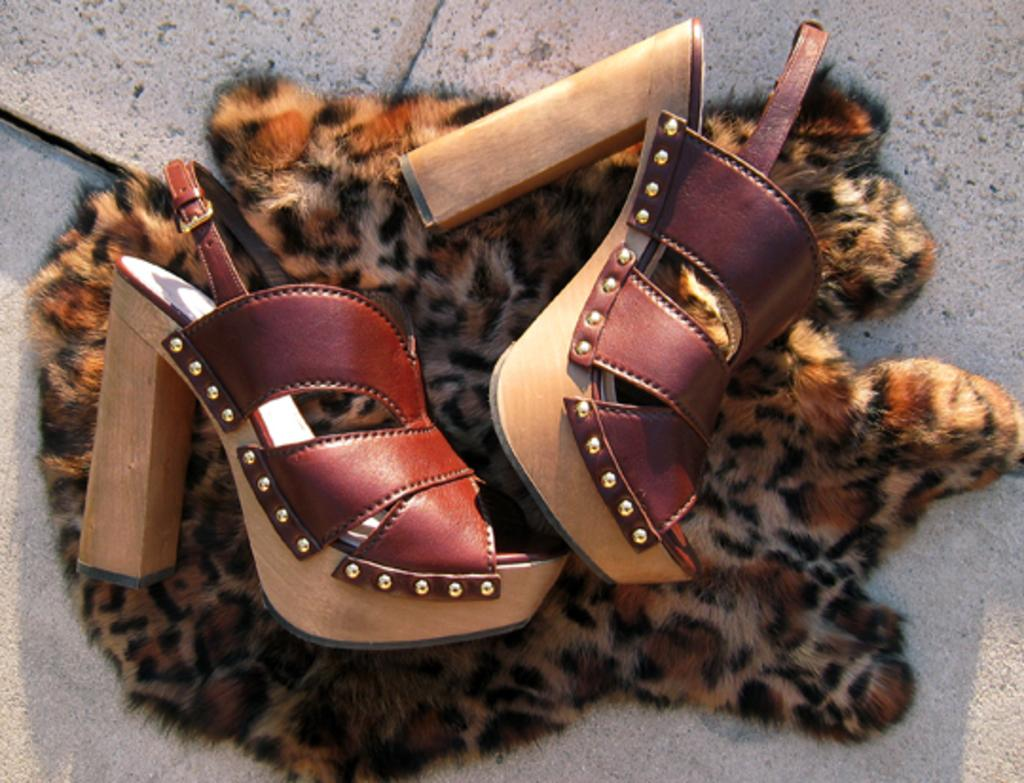What can be seen in the image? There is an object and sandals in the image. What type of footwear is present in the image? There are sandals in the image. Where are the object and sandals located? Both the object and sandals are on a surface. What type of lock is used to secure the sandals in the image? There is no lock present in the image; the sandals are simply placed on a surface. What type of cracker is visible in the image? There are no crackers present in the image. 